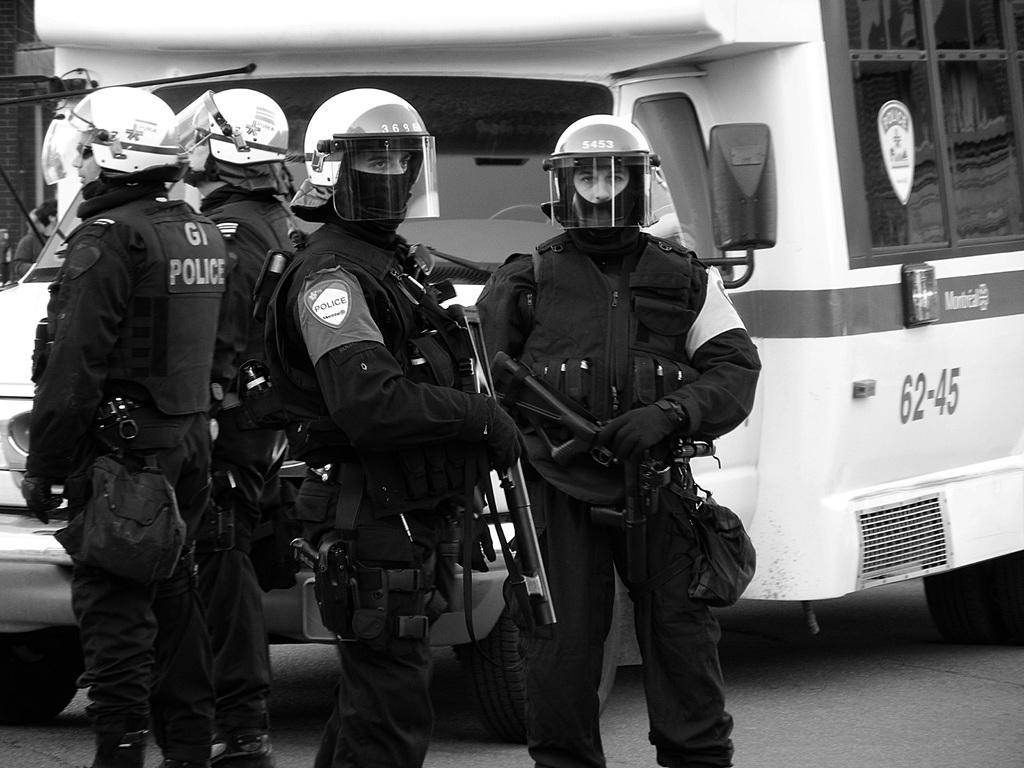How would you summarize this image in a sentence or two? In the center of the image there are police persons standing. In the background of the image there is a van. 